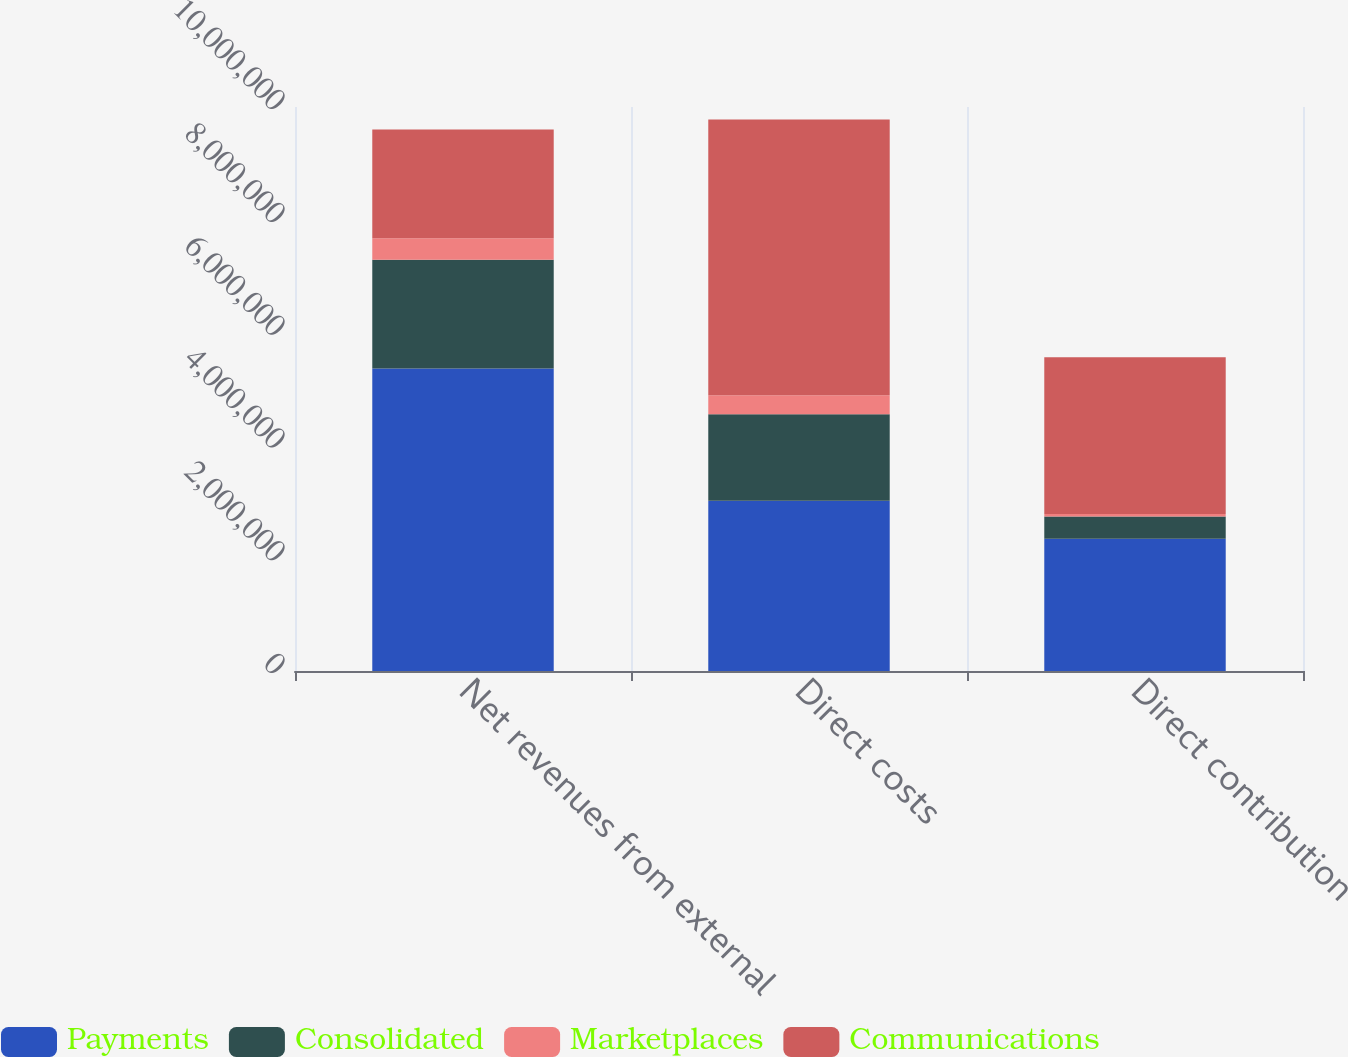Convert chart to OTSL. <chart><loc_0><loc_0><loc_500><loc_500><stacked_bar_chart><ecel><fcel>Net revenues from external<fcel>Direct costs<fcel>Direct contribution<nl><fcel>Payments<fcel>5.36389e+06<fcel>3.0179e+06<fcel>2.346e+06<nl><fcel>Consolidated<fcel>1.92662e+06<fcel>1.53463e+06<fcel>391989<nl><fcel>Marketplaces<fcel>381822<fcel>337338<fcel>44484<nl><fcel>Communications<fcel>1.92662e+06<fcel>4.88986e+06<fcel>2.78247e+06<nl></chart> 